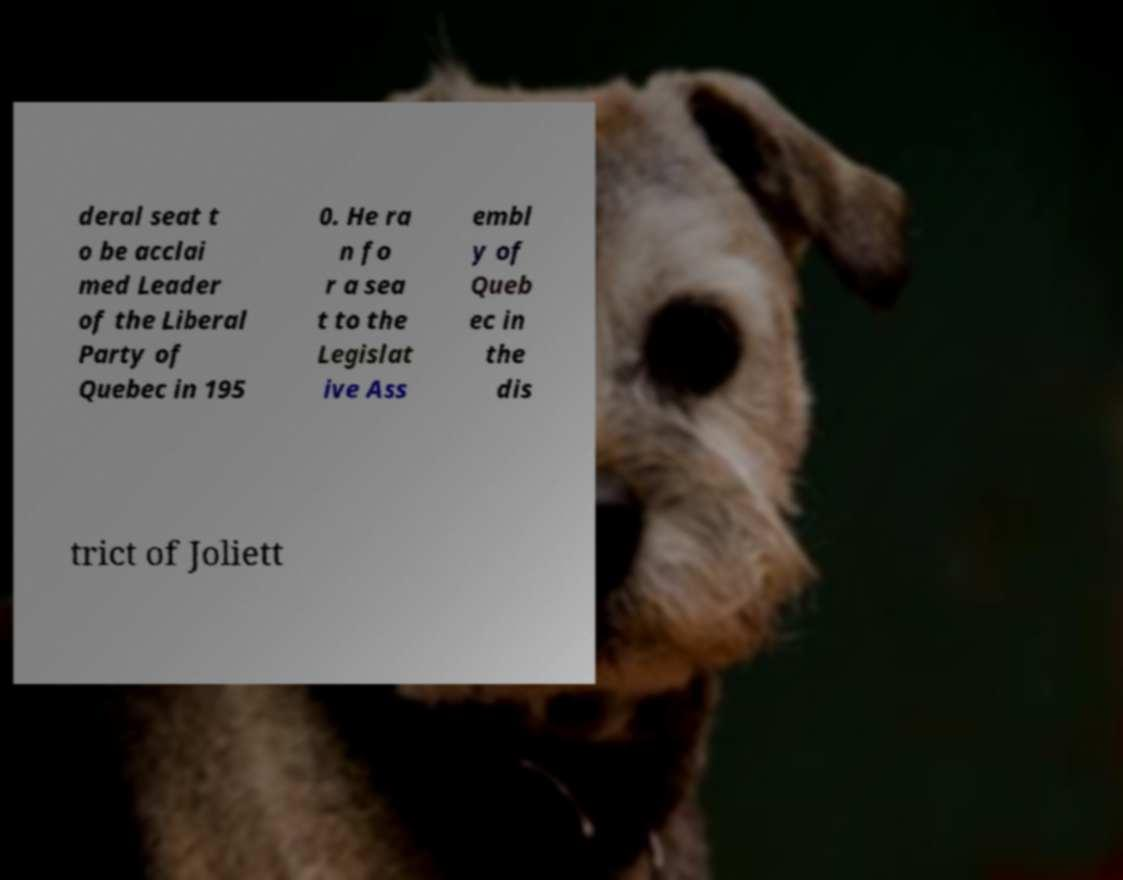Can you read and provide the text displayed in the image?This photo seems to have some interesting text. Can you extract and type it out for me? deral seat t o be acclai med Leader of the Liberal Party of Quebec in 195 0. He ra n fo r a sea t to the Legislat ive Ass embl y of Queb ec in the dis trict of Joliett 